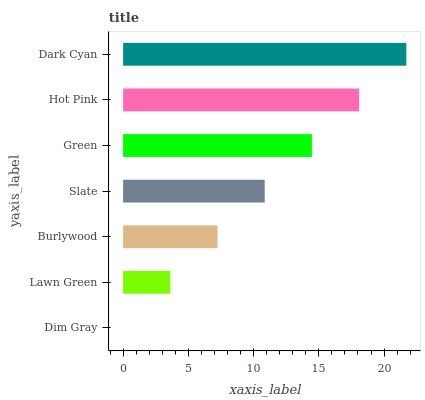Is Dim Gray the minimum?
Answer yes or no. Yes. Is Dark Cyan the maximum?
Answer yes or no. Yes. Is Lawn Green the minimum?
Answer yes or no. No. Is Lawn Green the maximum?
Answer yes or no. No. Is Lawn Green greater than Dim Gray?
Answer yes or no. Yes. Is Dim Gray less than Lawn Green?
Answer yes or no. Yes. Is Dim Gray greater than Lawn Green?
Answer yes or no. No. Is Lawn Green less than Dim Gray?
Answer yes or no. No. Is Slate the high median?
Answer yes or no. Yes. Is Slate the low median?
Answer yes or no. Yes. Is Lawn Green the high median?
Answer yes or no. No. Is Dim Gray the low median?
Answer yes or no. No. 